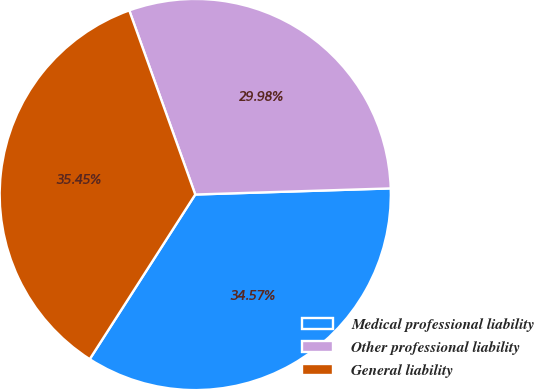Convert chart to OTSL. <chart><loc_0><loc_0><loc_500><loc_500><pie_chart><fcel>Medical professional liability<fcel>Other professional liability<fcel>General liability<nl><fcel>34.57%<fcel>29.98%<fcel>35.45%<nl></chart> 